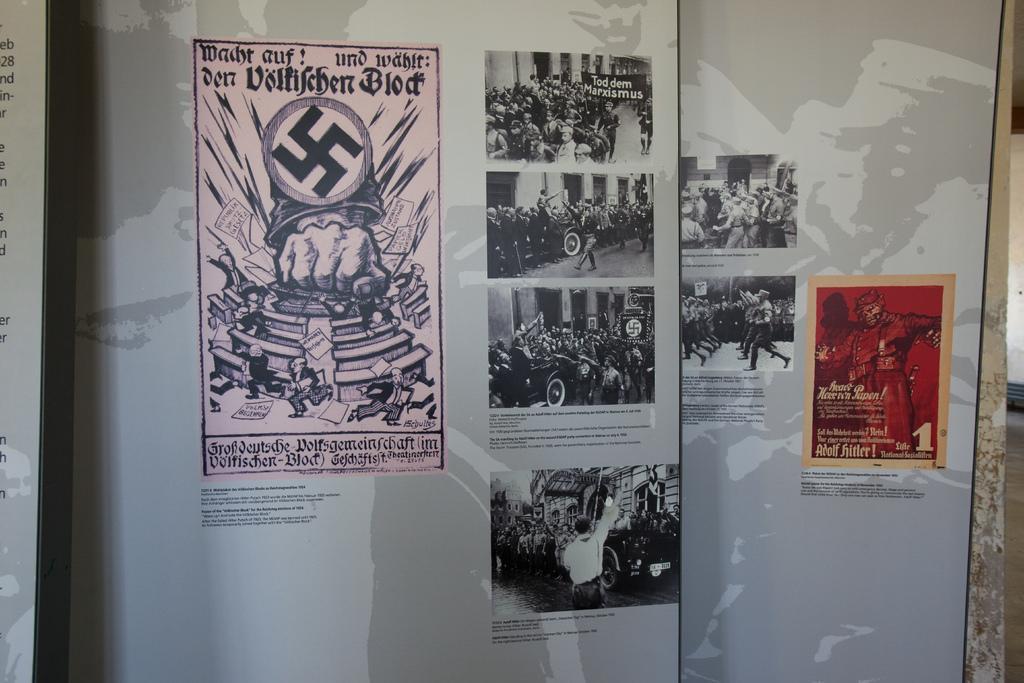Please provide a concise description of this image. The picture consists of banners, in the banner there are posters of communism and there is text. On the right it is well. 